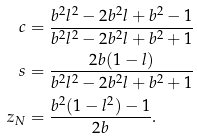<formula> <loc_0><loc_0><loc_500><loc_500>c & = \frac { b ^ { 2 } l ^ { 2 } - 2 b ^ { 2 } l + b ^ { 2 } - 1 } { b ^ { 2 } l ^ { 2 } - 2 b ^ { 2 } l + b ^ { 2 } + 1 } \\ s & = \frac { 2 b ( 1 - l ) } { b ^ { 2 } l ^ { 2 } - 2 b ^ { 2 } l + b ^ { 2 } + 1 } \\ z _ { N } & = \frac { b ^ { 2 } ( 1 - l ^ { 2 } ) - 1 } { 2 b } .</formula> 